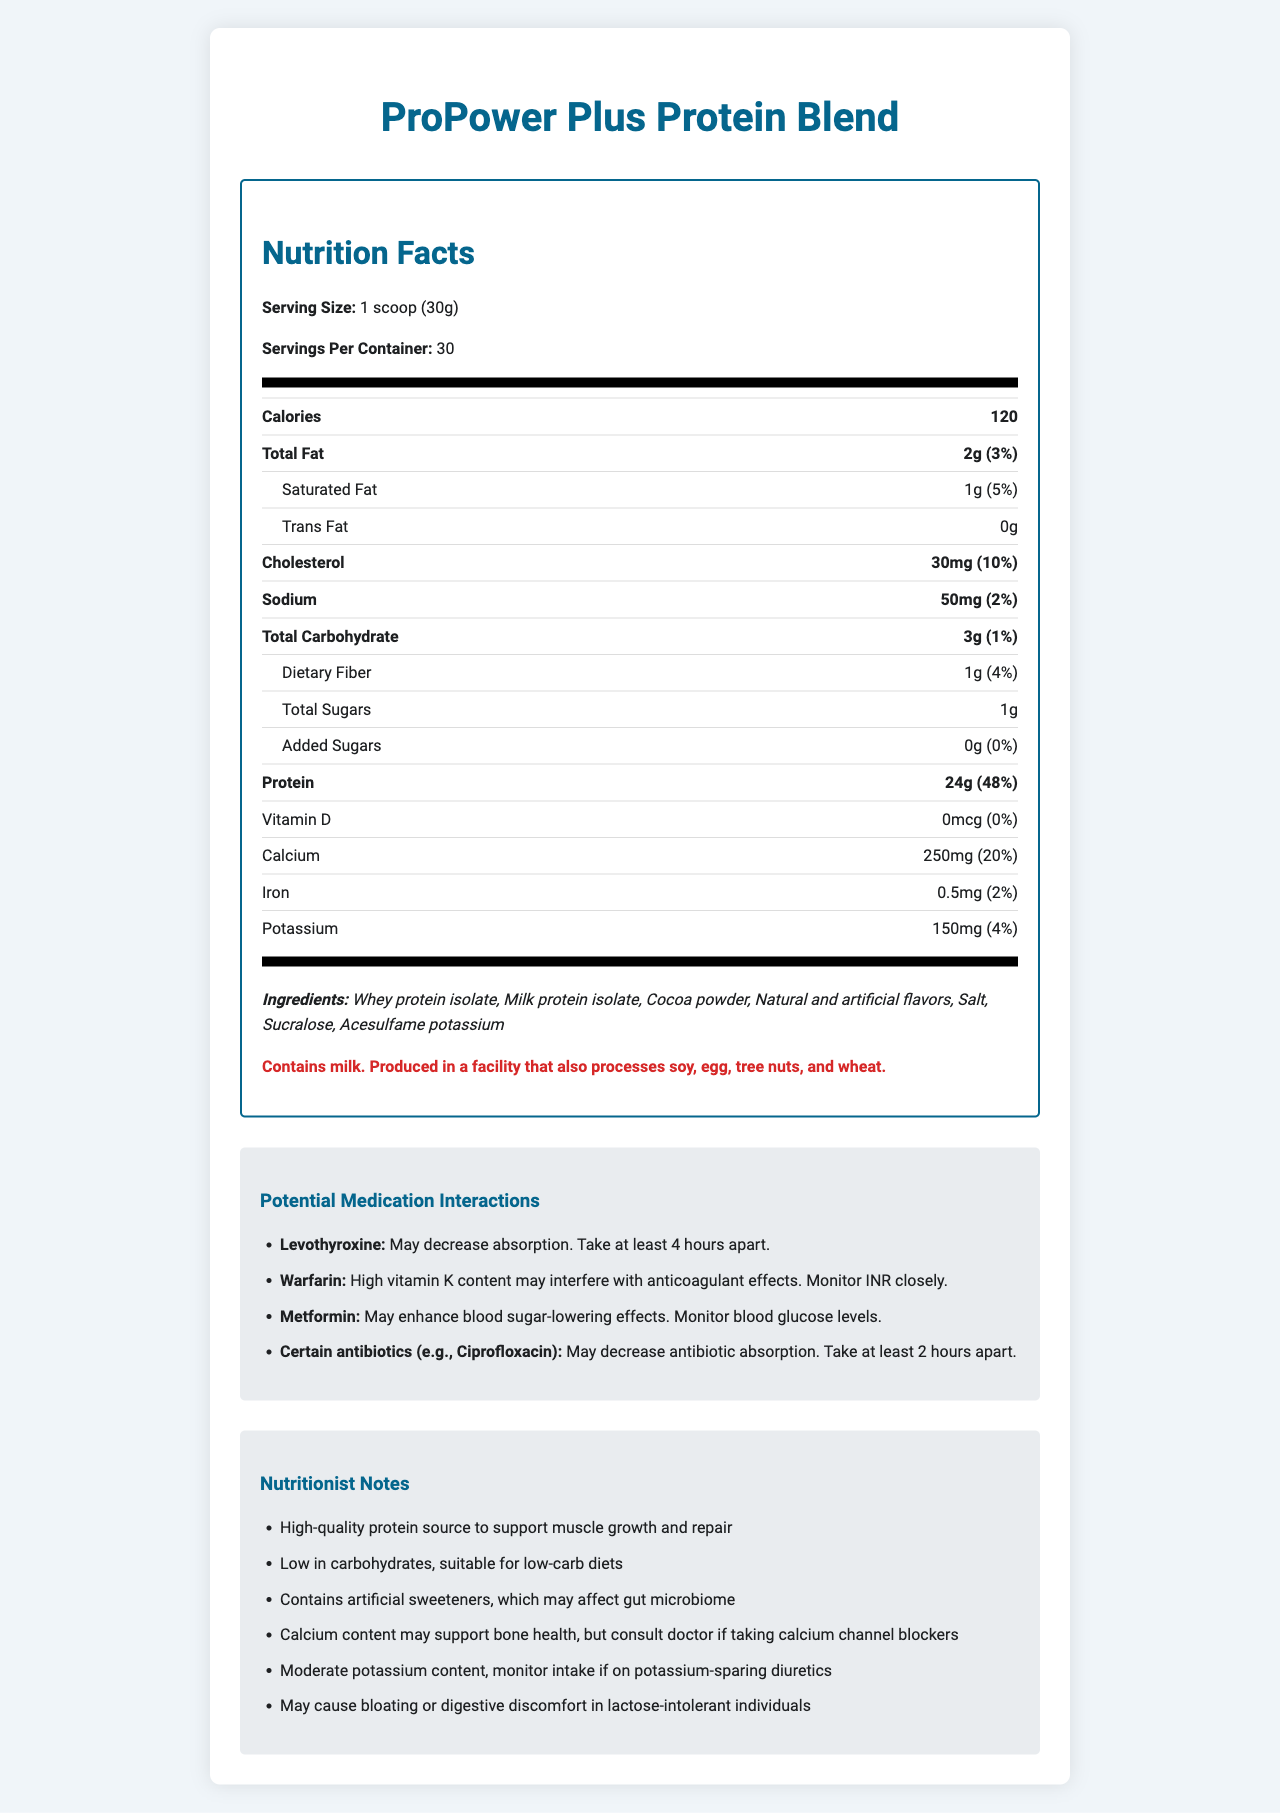what is the serving size of ProPower Plus Protein Blend? The serving size is specified as "1 scoop (30g)" on the nutrition label.
Answer: 1 scoop (30g) how many calories are there in one serving of ProPower Plus Protein Blend? The label states that there are 120 calories per serving.
Answer: 120 what is the total fat content per serving? The label lists the total fat content as 2g per serving.
Answer: 2g which ingredient is present in the highest amount? Ingredients are usually listed in descending order of quantity, so the first ingredient is present in the highest amount.
Answer: Whey protein isolate what is the daily value percentage of calcium per serving? The nutrition label shows that each serving contains 20% of the daily value for calcium.
Answer: 20% what should you do if you are taking Levothyroxine? The medication interactions section informs that Levothyroxine absorption may be decreased and suggests taking it at least 4 hours apart.
Answer: Take at least 4 hours apart why might someone on Metformin need to monitor their blood glucose levels when using this supplement? The medication interactions section notes that the supplement may enhance the blood sugar-lowering effects of Metformin, requiring blood glucose monitoring.
Answer: The supplement may enhance blood sugar-lowering effects what are the potential allergens in this product? The allergen information section states that the product contains milk and is produced in a facility that also processes other allergens.
Answer: Contains milk. Produced in a facility that also processes soy, egg, tree nuts, and wheat. which of the following ingredients might affect the gut microbiome? A. Cocoa powder B. Whey protein isolate C. Sucralose The nutritionist notes mention that artificial sweeteners, such as Sucralose, may affect the gut microbiome.
Answer: C. Sucralose which ingredient provides a high-quality protein source? A. Milk protein isolate B. Natural and artificial flavors C. Salt The nutritionist notes indicate that "High-quality protein source" refers to whey protein isolate and milk protein isolate.
Answer: A. Milk protein isolate does this supplement contain added sugars? The nutrition label shows the amount of added sugars as 0g.
Answer: No what is the main idea of this document? This document summarizes the nutritional content, ingredients, allergens, potential medication interactions, and expert notes on the ProPower Plus Protein Blend protein powder.
Answer: The document provides detailed nutrition facts, ingredients, allergens, potential medication interactions, and nutritional notes for the ProPower Plus Protein Blend. what is the price of the ProPower Plus Protein Blend? The document does not provide any pricing information for the product.
Answer: Not enough information 